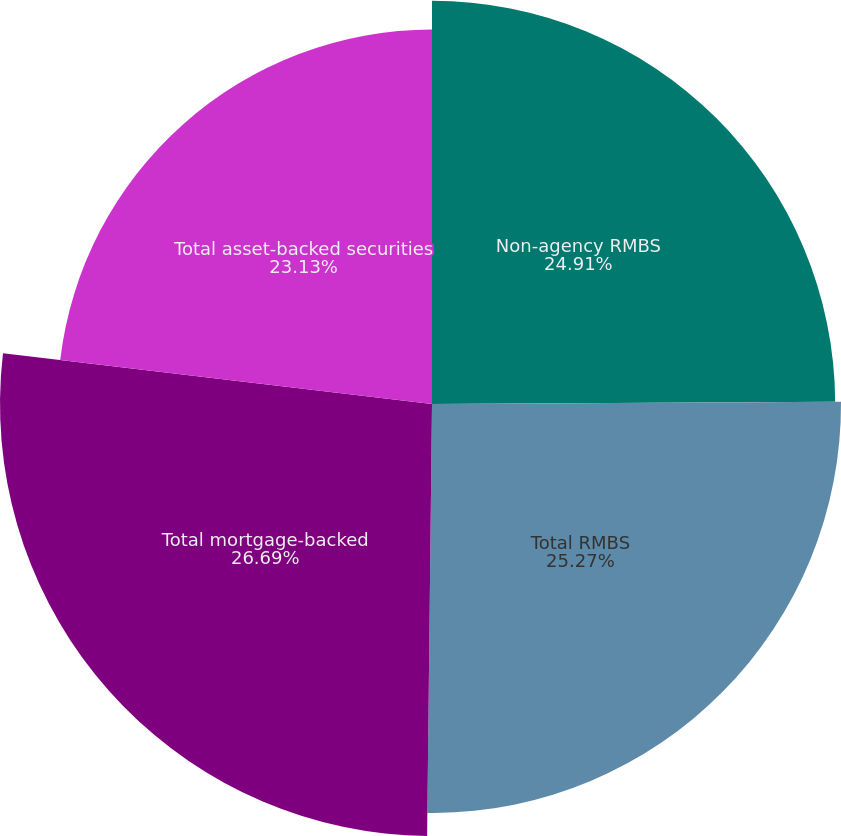Convert chart. <chart><loc_0><loc_0><loc_500><loc_500><pie_chart><fcel>Non-agency RMBS<fcel>Total RMBS<fcel>Total mortgage-backed<fcel>Total asset-backed securities<nl><fcel>24.91%<fcel>25.27%<fcel>26.69%<fcel>23.13%<nl></chart> 